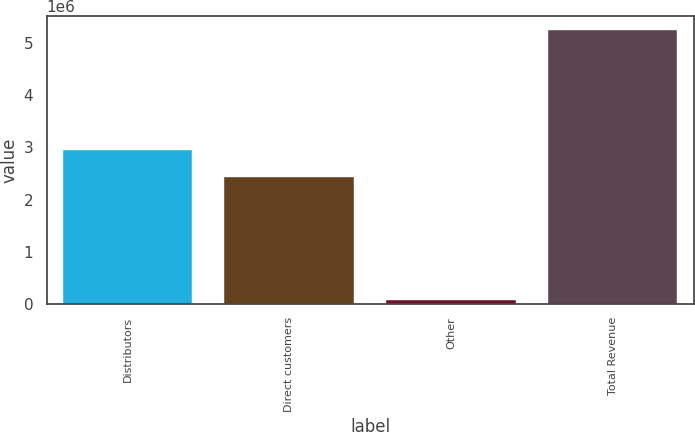Convert chart to OTSL. <chart><loc_0><loc_0><loc_500><loc_500><bar_chart><fcel>Distributors<fcel>Direct customers<fcel>Other<fcel>Total Revenue<nl><fcel>2.9419e+06<fcel>2.42451e+06<fcel>72505<fcel>5.24635e+06<nl></chart> 